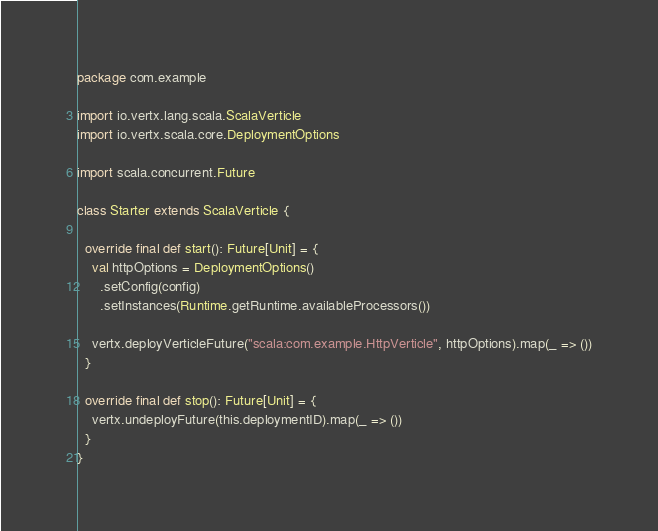Convert code to text. <code><loc_0><loc_0><loc_500><loc_500><_Scala_>package com.example

import io.vertx.lang.scala.ScalaVerticle
import io.vertx.scala.core.DeploymentOptions

import scala.concurrent.Future

class Starter extends ScalaVerticle {

  override final def start(): Future[Unit] = {
    val httpOptions = DeploymentOptions()
      .setConfig(config)
      .setInstances(Runtime.getRuntime.availableProcessors())

    vertx.deployVerticleFuture("scala:com.example.HttpVerticle", httpOptions).map(_ => ())
  }

  override final def stop(): Future[Unit] = {
    vertx.undeployFuture(this.deploymentID).map(_ => ())
  }
}
</code> 